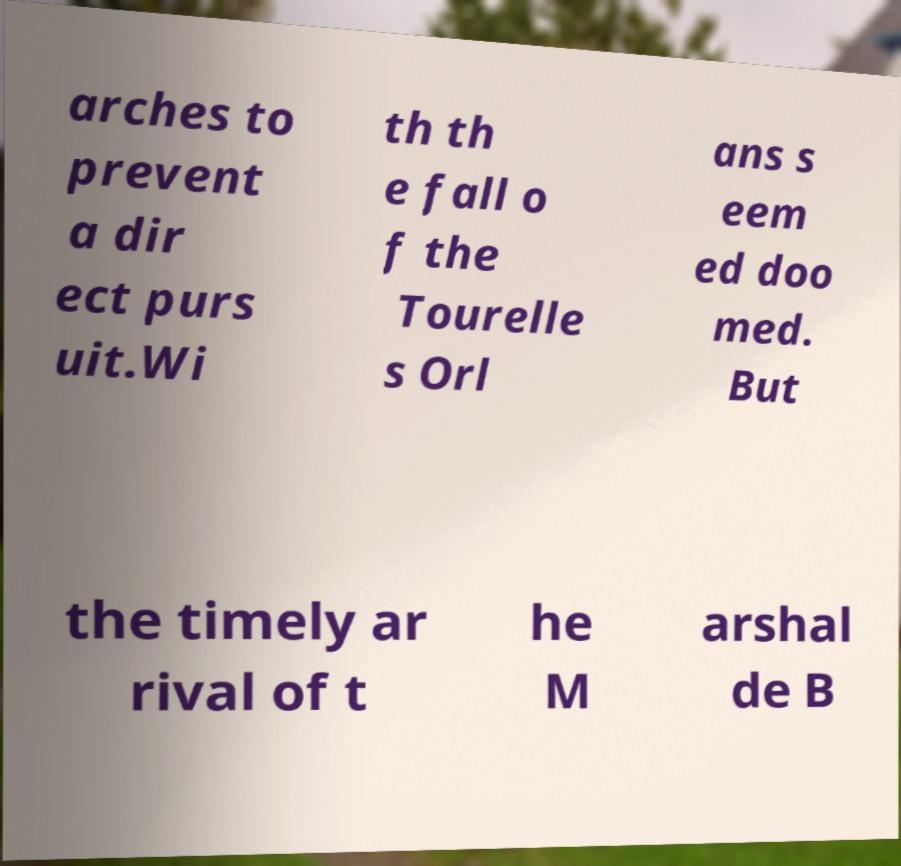Can you accurately transcribe the text from the provided image for me? arches to prevent a dir ect purs uit.Wi th th e fall o f the Tourelle s Orl ans s eem ed doo med. But the timely ar rival of t he M arshal de B 